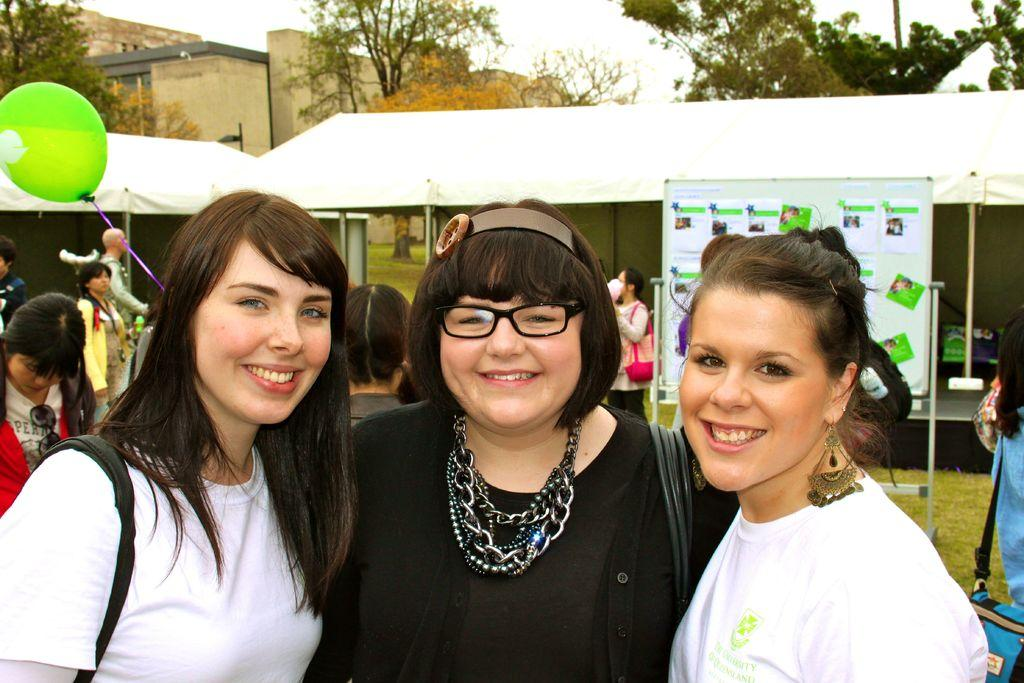How many women are in the image? There are three women in the image. What are the women doing in the image? The women are watching and smiling. Can you describe the background of the image? In the background of the image, there are people, a board, rods, tents, a balloon, grass, trees, walls, and the sky. What type of sock is hanging from the tree in the image? There is no sock present in the image; it only features a balloon in the background. What angle is the rain falling at in the image? There is no rain present in the image, so it is not possible to determine the angle at which rain would fall. 